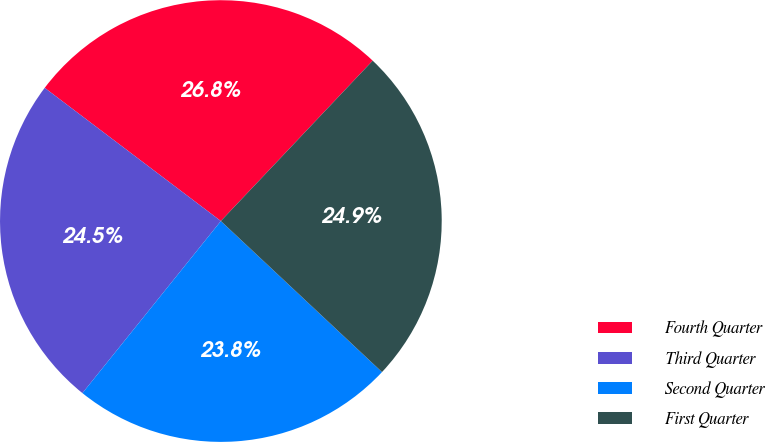Convert chart. <chart><loc_0><loc_0><loc_500><loc_500><pie_chart><fcel>Fourth Quarter<fcel>Third Quarter<fcel>Second Quarter<fcel>First Quarter<nl><fcel>26.76%<fcel>24.52%<fcel>23.8%<fcel>24.92%<nl></chart> 